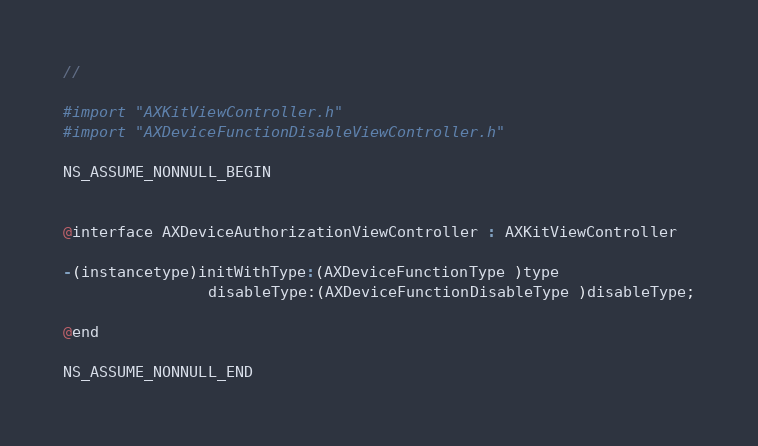<code> <loc_0><loc_0><loc_500><loc_500><_C_>//

#import "AXKitViewController.h"
#import "AXDeviceFunctionDisableViewController.h"

NS_ASSUME_NONNULL_BEGIN


@interface AXDeviceAuthorizationViewController : AXKitViewController

-(instancetype)initWithType:(AXDeviceFunctionType )type
                disableType:(AXDeviceFunctionDisableType )disableType;

@end

NS_ASSUME_NONNULL_END
</code> 